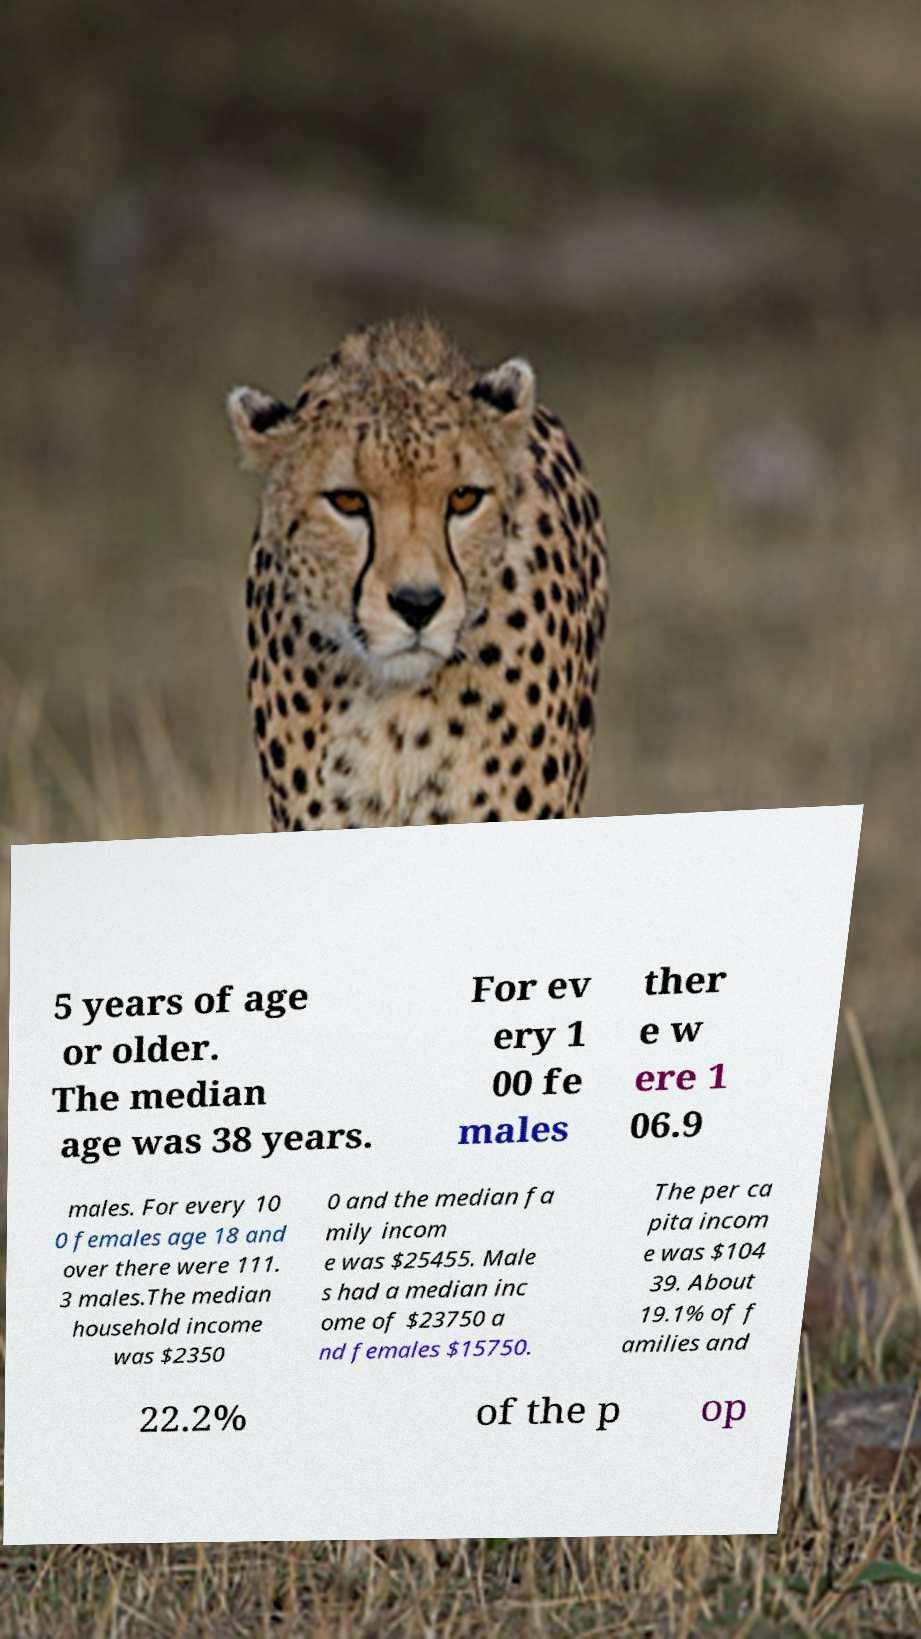Can you read and provide the text displayed in the image?This photo seems to have some interesting text. Can you extract and type it out for me? 5 years of age or older. The median age was 38 years. For ev ery 1 00 fe males ther e w ere 1 06.9 males. For every 10 0 females age 18 and over there were 111. 3 males.The median household income was $2350 0 and the median fa mily incom e was $25455. Male s had a median inc ome of $23750 a nd females $15750. The per ca pita incom e was $104 39. About 19.1% of f amilies and 22.2% of the p op 